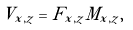Convert formula to latex. <formula><loc_0><loc_0><loc_500><loc_500>V _ { x , z } = F _ { x , z } M _ { x , z } ,</formula> 